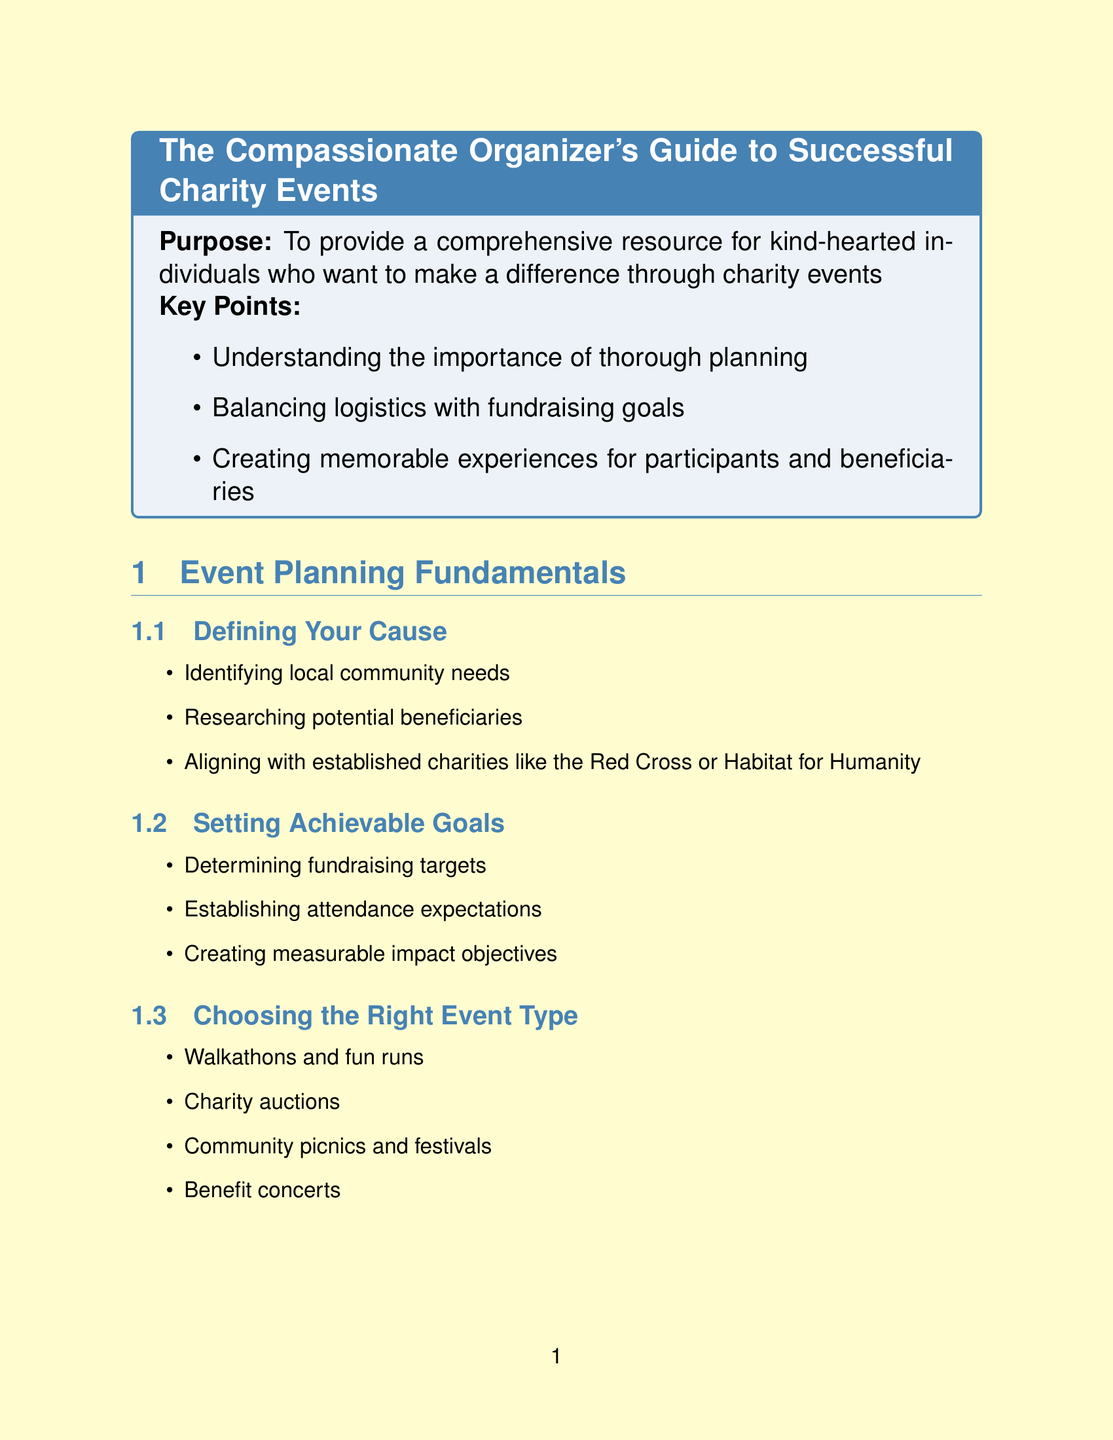what is the title of the manual? The title is mentioned at the beginning of the document.
Answer: The Compassionate Organizer's Guide to Successful Charity Events how many chapters are in the manual? The number of chapters can be counted from the table of contents section.
Answer: Five name one type of event suggested in the manual. The document lists various event types in the section about choosing the right event type.
Answer: Charity auctions what is a key point in the introduction? Key points are provided in bullet form within the introduction.
Answer: Creating memorable experiences for participants and beneficiaries what is one of the appendices included in the document? The information regarding appendices can be found in the appendices section.
Answer: Sample Templates what should you provide to volunteers for appreciation? The manual provides suggestions for volunteer appreciation in the relevant section.
Answer: Refreshments and breaks during the event which software is recommended for volunteer management? The document lists software options in the volunteer coordination section.
Answer: VolunteerLocal how many sections are in the Fundraising Strategies chapter? The number of sections can be counted from the chapter outline.
Answer: Three 